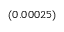Convert formula to latex. <formula><loc_0><loc_0><loc_500><loc_500>_ { ( 0 . 0 0 0 2 5 ) }</formula> 